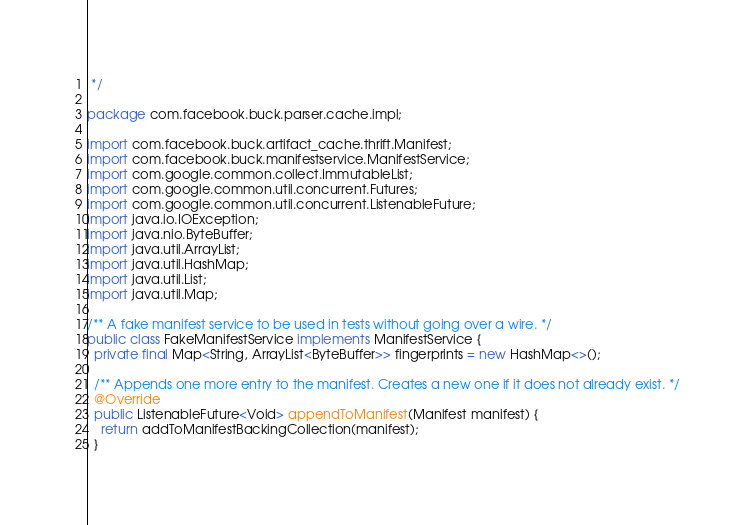Convert code to text. <code><loc_0><loc_0><loc_500><loc_500><_Java_> */

package com.facebook.buck.parser.cache.impl;

import com.facebook.buck.artifact_cache.thrift.Manifest;
import com.facebook.buck.manifestservice.ManifestService;
import com.google.common.collect.ImmutableList;
import com.google.common.util.concurrent.Futures;
import com.google.common.util.concurrent.ListenableFuture;
import java.io.IOException;
import java.nio.ByteBuffer;
import java.util.ArrayList;
import java.util.HashMap;
import java.util.List;
import java.util.Map;

/** A fake manifest service to be used in tests without going over a wire. */
public class FakeManifestService implements ManifestService {
  private final Map<String, ArrayList<ByteBuffer>> fingerprints = new HashMap<>();

  /** Appends one more entry to the manifest. Creates a new one if it does not already exist. */
  @Override
  public ListenableFuture<Void> appendToManifest(Manifest manifest) {
    return addToManifestBackingCollection(manifest);
  }
</code> 